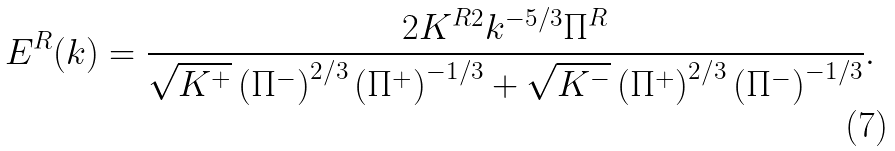<formula> <loc_0><loc_0><loc_500><loc_500>E ^ { R } ( k ) = \frac { 2 K ^ { R 2 } k ^ { - 5 / 3 } \Pi ^ { R } } { \sqrt { K ^ { + } } \left ( \Pi ^ { - } \right ) ^ { 2 / 3 } \left ( \Pi ^ { + } \right ) ^ { - 1 / 3 } + \sqrt { K ^ { - } } \left ( \Pi ^ { + } \right ) ^ { 2 / 3 } \left ( \Pi ^ { - } \right ) ^ { - 1 / 3 } } .</formula> 